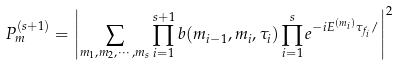<formula> <loc_0><loc_0><loc_500><loc_500>P ^ { ( s + 1 ) } _ { m } = \left | \sum _ { m _ { 1 } , m _ { 2 } , \cdots , m _ { s } } \prod _ { i = 1 } ^ { s + 1 } b ( m _ { i - 1 } , m _ { i } , \tau _ { i } ) \prod _ { i = 1 } ^ { s } e ^ { - i E ^ { ( m _ { i } ) } \tau _ { f _ { i } } / } \right | ^ { 2 }</formula> 